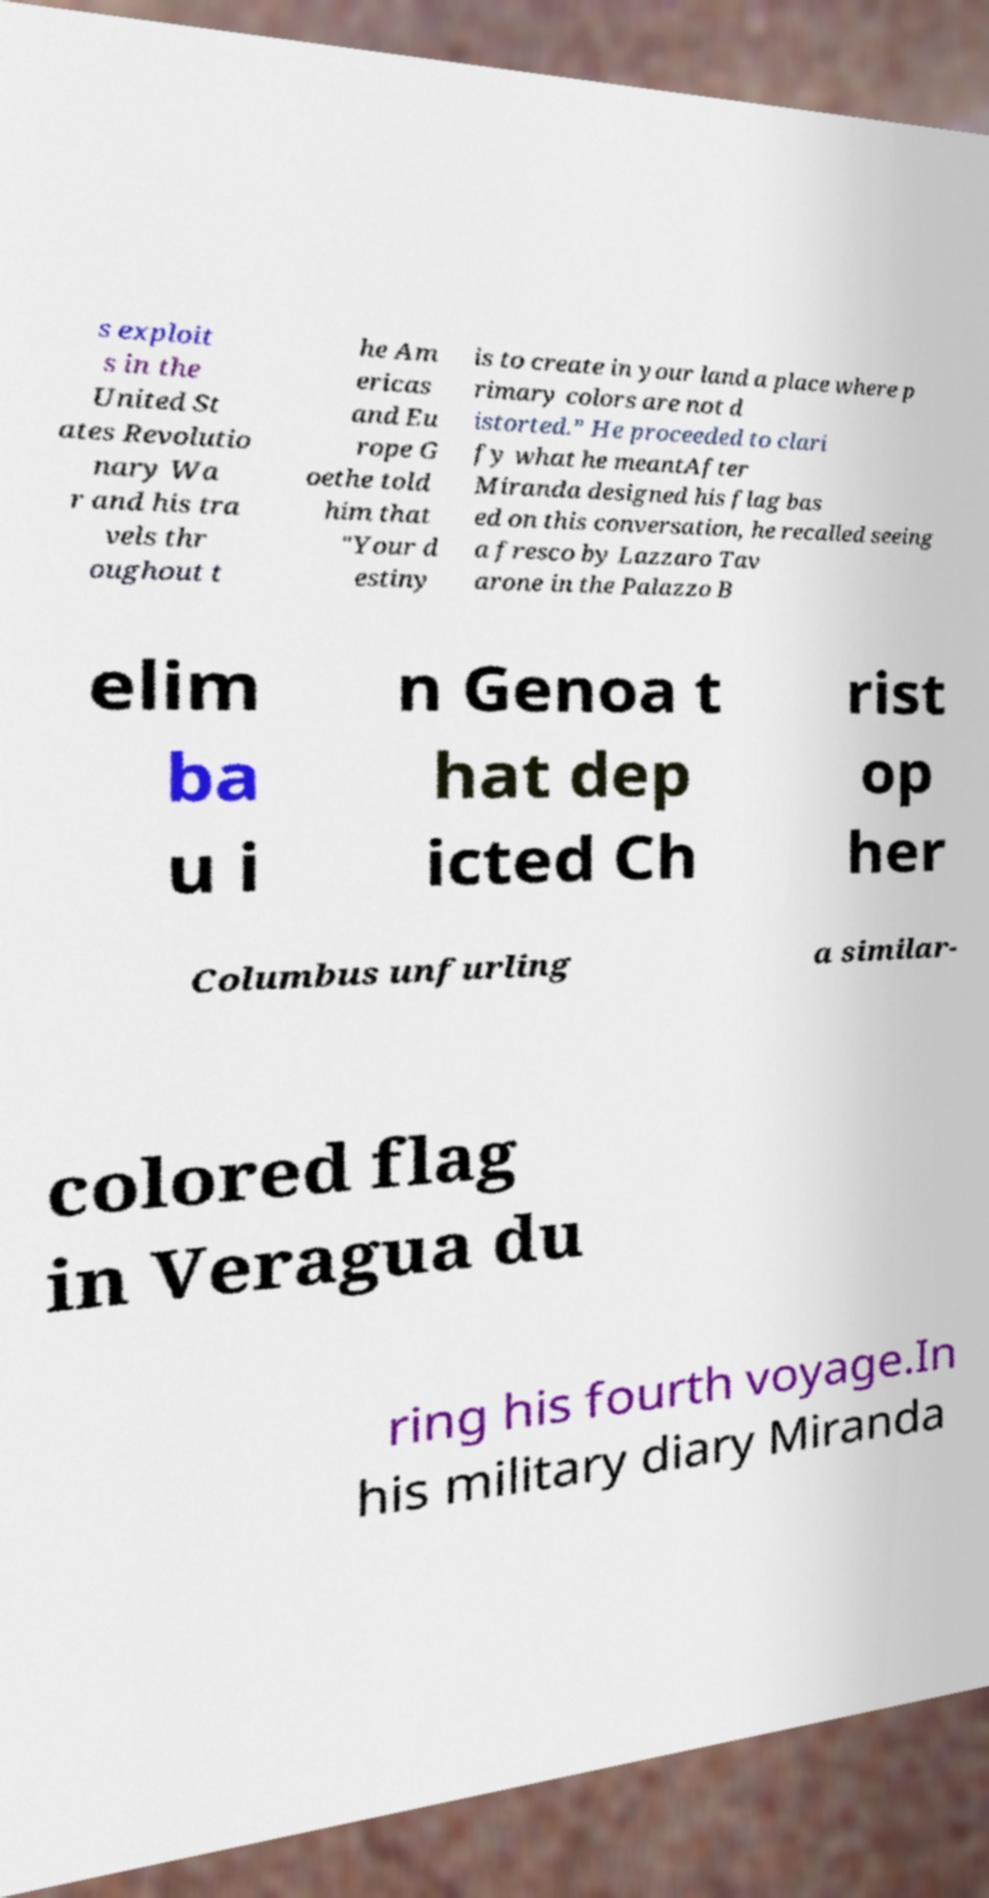Please identify and transcribe the text found in this image. s exploit s in the United St ates Revolutio nary Wa r and his tra vels thr oughout t he Am ericas and Eu rope G oethe told him that "Your d estiny is to create in your land a place where p rimary colors are not d istorted.” He proceeded to clari fy what he meantAfter Miranda designed his flag bas ed on this conversation, he recalled seeing a fresco by Lazzaro Tav arone in the Palazzo B elim ba u i n Genoa t hat dep icted Ch rist op her Columbus unfurling a similar- colored flag in Veragua du ring his fourth voyage.In his military diary Miranda 